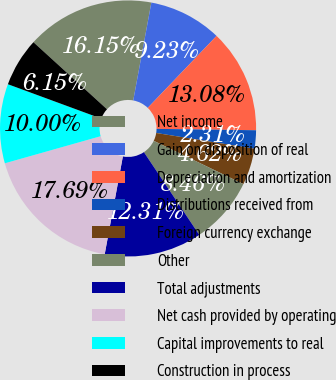Convert chart. <chart><loc_0><loc_0><loc_500><loc_500><pie_chart><fcel>Net income<fcel>Gain on disposition of real<fcel>Depreciation and amortization<fcel>Distributions received from<fcel>Foreign currency exchange<fcel>Other<fcel>Total adjustments<fcel>Net cash provided by operating<fcel>Capital improvements to real<fcel>Construction in process<nl><fcel>16.15%<fcel>9.23%<fcel>13.08%<fcel>2.31%<fcel>4.62%<fcel>8.46%<fcel>12.31%<fcel>17.69%<fcel>10.0%<fcel>6.15%<nl></chart> 